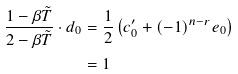<formula> <loc_0><loc_0><loc_500><loc_500>\frac { 1 - \beta \tilde { T } } { 2 - \beta \tilde { T } } \cdot d _ { 0 } & = \frac { 1 } { 2 } \left ( c ^ { \prime } _ { 0 } + ( - 1 ) ^ { n - r } e _ { 0 } \right ) \\ & = 1</formula> 